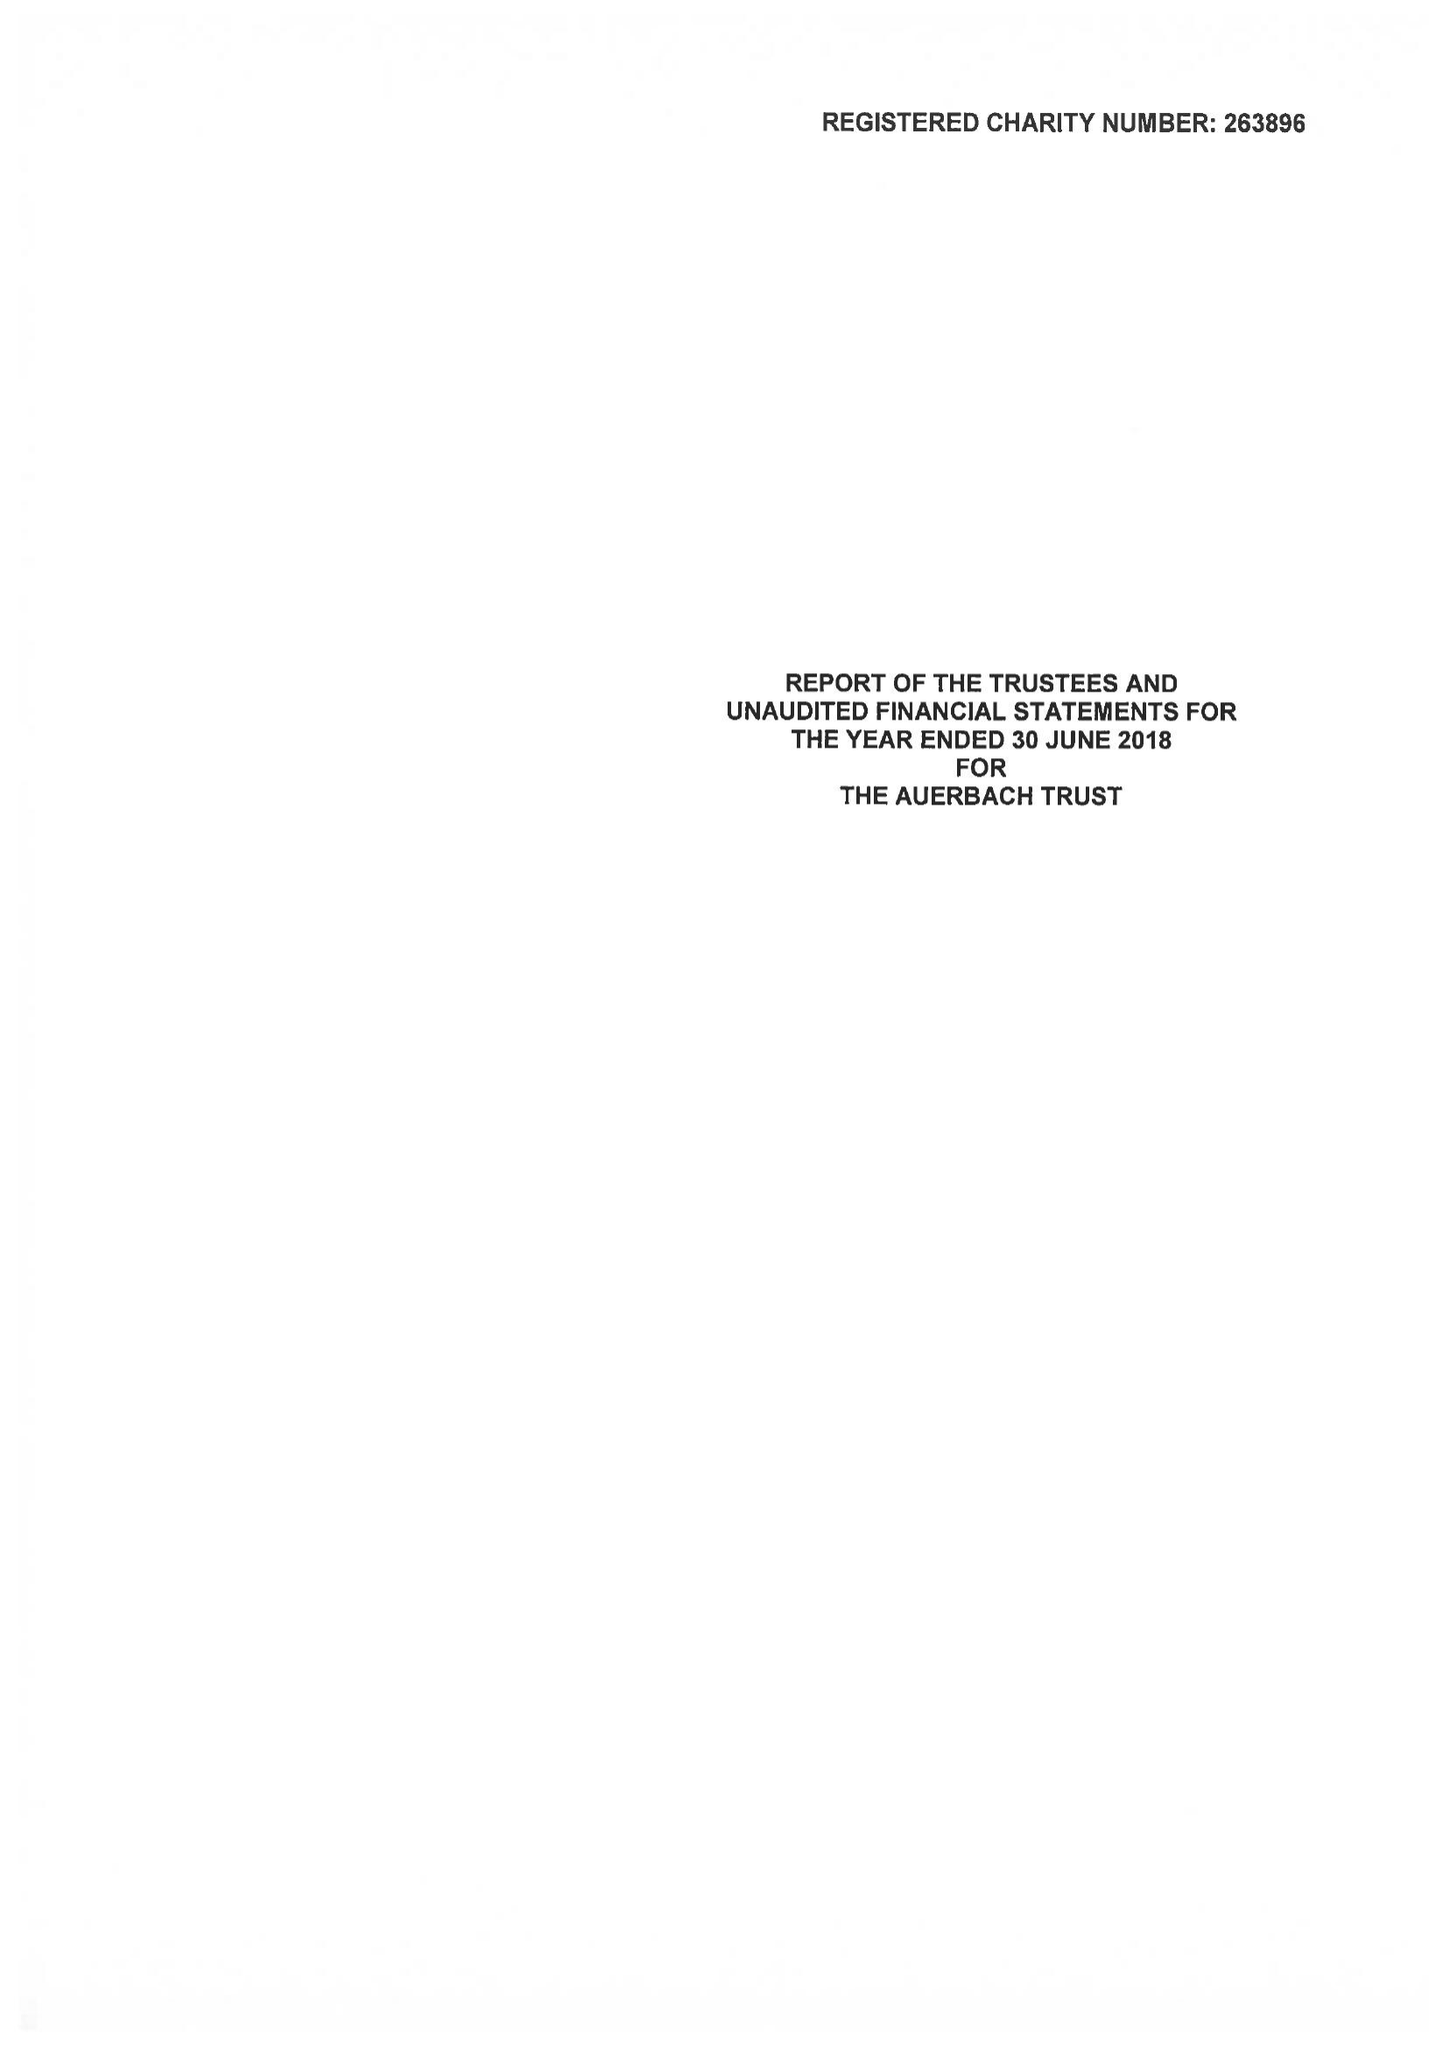What is the value for the address__postcode?
Answer the question using a single word or phrase. NW1 4RD 